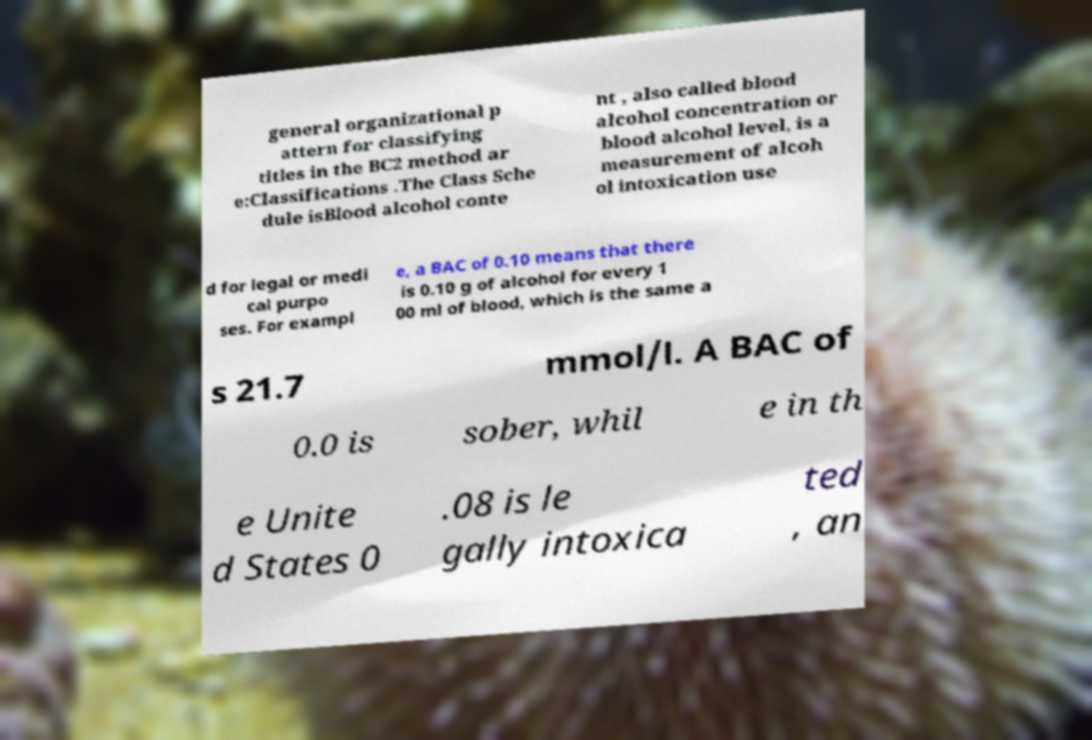Could you extract and type out the text from this image? general organizational p attern for classifying titles in the BC2 method ar e:Classifications .The Class Sche dule isBlood alcohol conte nt , also called blood alcohol concentration or blood alcohol level, is a measurement of alcoh ol intoxication use d for legal or medi cal purpo ses. For exampl e, a BAC of 0.10 means that there is 0.10 g of alcohol for every 1 00 ml of blood, which is the same a s 21.7 mmol/l. A BAC of 0.0 is sober, whil e in th e Unite d States 0 .08 is le gally intoxica ted , an 